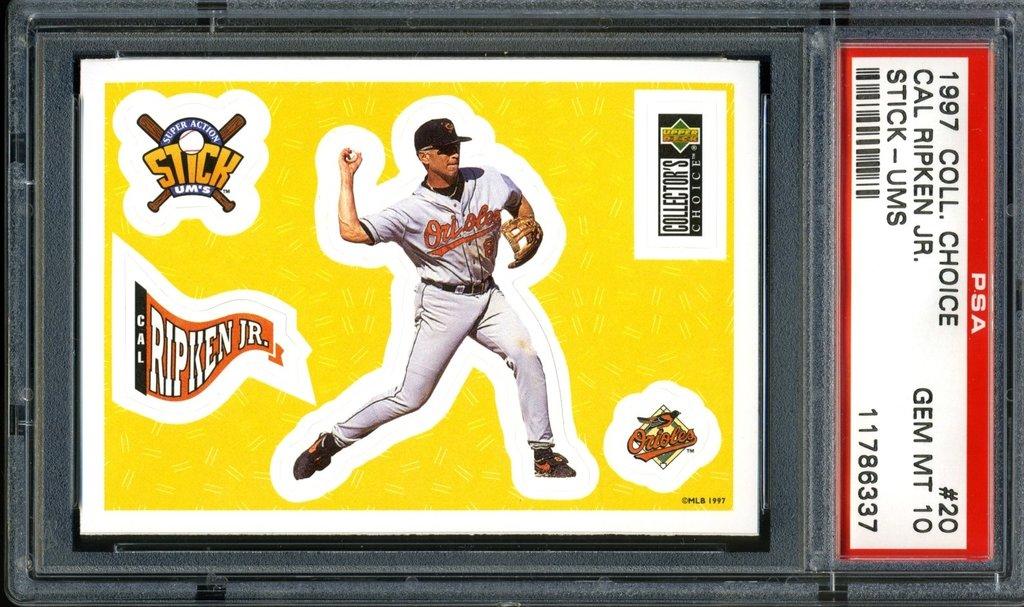What year is this baseball card from?
Provide a short and direct response. 1997. 